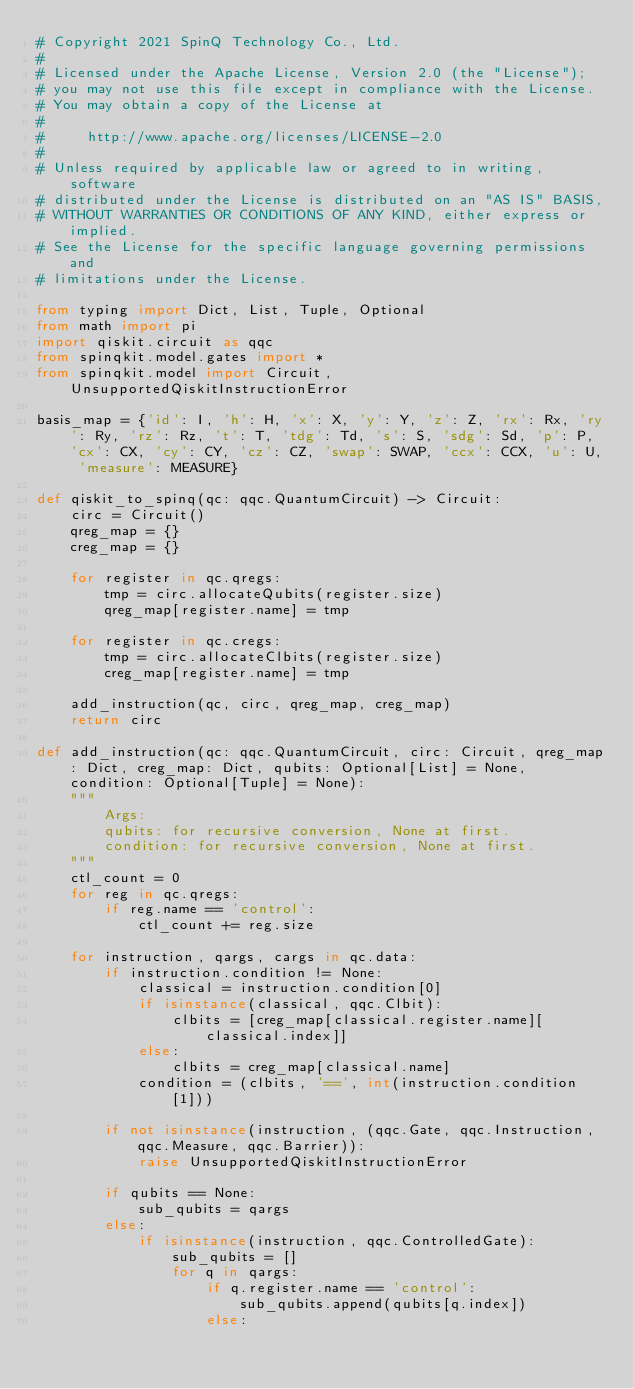Convert code to text. <code><loc_0><loc_0><loc_500><loc_500><_Python_># Copyright 2021 SpinQ Technology Co., Ltd.
#
# Licensed under the Apache License, Version 2.0 (the "License");
# you may not use this file except in compliance with the License.
# You may obtain a copy of the License at
#
#     http://www.apache.org/licenses/LICENSE-2.0
#
# Unless required by applicable law or agreed to in writing, software
# distributed under the License is distributed on an "AS IS" BASIS,
# WITHOUT WARRANTIES OR CONDITIONS OF ANY KIND, either express or implied.
# See the License for the specific language governing permissions and
# limitations under the License.

from typing import Dict, List, Tuple, Optional
from math import pi
import qiskit.circuit as qqc
from spinqkit.model.gates import * 
from spinqkit.model import Circuit, UnsupportedQiskitInstructionError

basis_map = {'id': I, 'h': H, 'x': X, 'y': Y, 'z': Z, 'rx': Rx, 'ry': Ry, 'rz': Rz, 't': T, 'tdg': Td, 's': S, 'sdg': Sd, 'p': P, 'cx': CX, 'cy': CY, 'cz': CZ, 'swap': SWAP, 'ccx': CCX, 'u': U, 'measure': MEASURE}

def qiskit_to_spinq(qc: qqc.QuantumCircuit) -> Circuit:
    circ = Circuit()
    qreg_map = {}
    creg_map = {}

    for register in qc.qregs:
        tmp = circ.allocateQubits(register.size)
        qreg_map[register.name] = tmp

    for register in qc.cregs:
        tmp = circ.allocateClbits(register.size)
        creg_map[register.name] = tmp

    add_instruction(qc, circ, qreg_map, creg_map)
    return circ

def add_instruction(qc: qqc.QuantumCircuit, circ: Circuit, qreg_map: Dict, creg_map: Dict, qubits: Optional[List] = None, condition: Optional[Tuple] = None):
    """
        Args:
        qubits: for recursive conversion, None at first.
        condition: for recursive conversion, None at first.
    """
    ctl_count = 0
    for reg in qc.qregs:
        if reg.name == 'control':
            ctl_count += reg.size
   
    for instruction, qargs, cargs in qc.data:
        if instruction.condition != None:
            classical = instruction.condition[0]
            if isinstance(classical, qqc.Clbit):
                clbits = [creg_map[classical.register.name][classical.index]]
            else:
                clbits = creg_map[classical.name]
            condition = (clbits, '==', int(instruction.condition[1]))        

        if not isinstance(instruction, (qqc.Gate, qqc.Instruction, qqc.Measure, qqc.Barrier)):
            raise UnsupportedQiskitInstructionError
        
        if qubits == None: 
            sub_qubits = qargs
        else:
            if isinstance(instruction, qqc.ControlledGate):
                sub_qubits = []
                for q in qargs:
                    if q.register.name == 'control':
                        sub_qubits.append(qubits[q.index])
                    else:</code> 